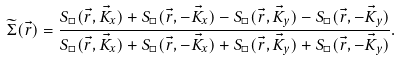Convert formula to latex. <formula><loc_0><loc_0><loc_500><loc_500>\widetilde { \Sigma } ( \vec { r } ) = \frac { S _ { \Box } ( \vec { r } , \vec { K } _ { x } ) + S _ { \Box } ( \vec { r } , - \vec { K } _ { x } ) - S _ { \Box } ( \vec { r } , \vec { K } _ { y } ) - S _ { \Box } ( \vec { r } , - \vec { K } _ { y } ) } { S _ { \Box } ( \vec { r } , \vec { K } _ { x } ) + S _ { \Box } ( \vec { r } , - \vec { K } _ { x } ) + S _ { \Box } ( \vec { r } , \vec { K } _ { y } ) + S _ { \Box } ( \vec { r } , - \vec { K } _ { y } ) } .</formula> 